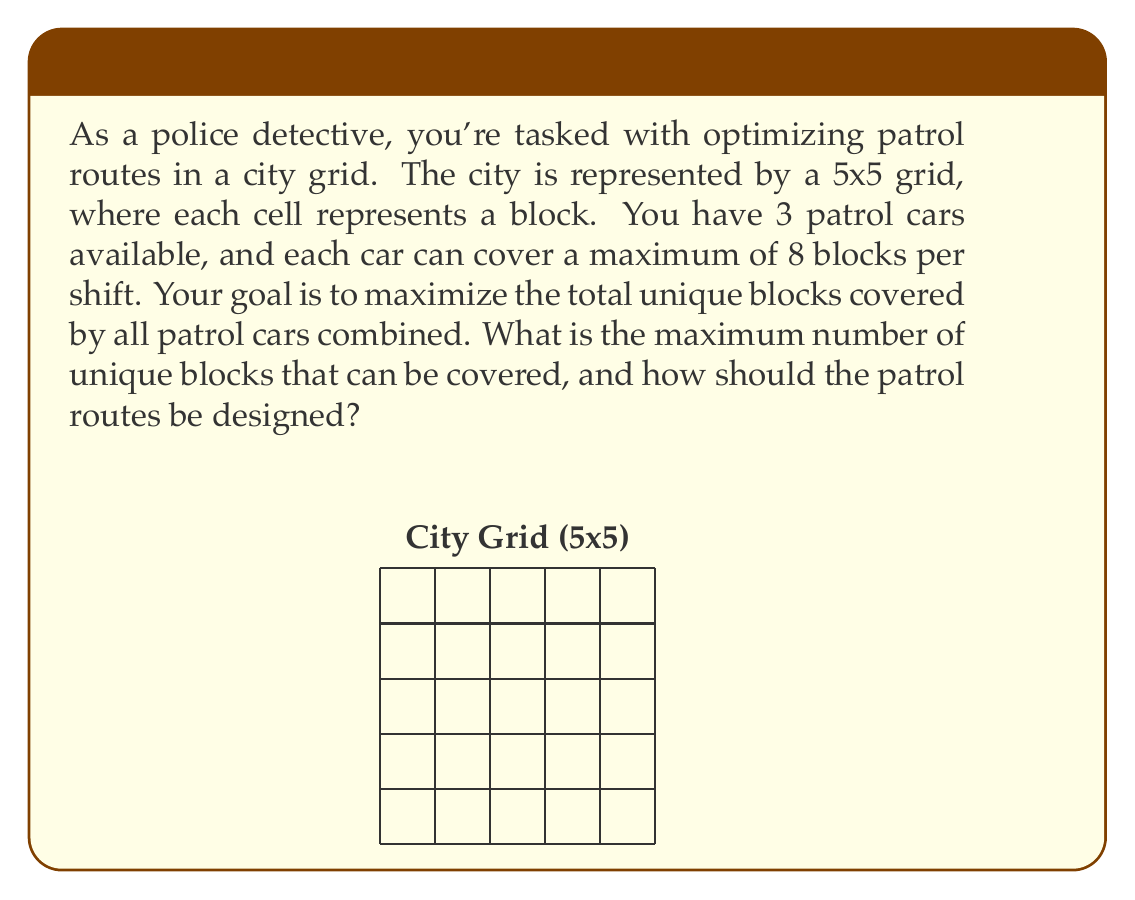Teach me how to tackle this problem. To solve this optimization problem, we need to consider the following:

1. The total area of the city grid is 5 x 5 = 25 blocks.
2. We have 3 patrol cars, each covering a maximum of 8 blocks.
3. The goal is to maximize unique block coverage, avoiding overlap.

Let's approach this step-by-step:

1. If there was no overlap, the maximum coverage would be:
   $3 \text{ cars} \times 8 \text{ blocks} = 24 \text{ blocks}$

2. However, we need to ensure that the routes are feasible within the 5x5 grid.

3. The optimal solution is to design routes that cover the maximum area with minimal overlap. One possible arrangement is:

   [asy]
   unitsize(1cm);
   for(int i=0; i<=5; ++i) {
     draw((0,i)--(5,i));
     draw((i,0)--(i,5));
   }
   draw((0,0)--(3,0)--(3,2)--(0,2)--cycle, blue);
   draw((2,2)--(5,2)--(5,4)--(2,4)--cycle, red);
   draw((0,3)--(3,3)--(3,5)--(0,5)--cycle, green);
   label("Car 1", (1.5,1), blue);
   label("Car 2", (3.5,3), red);
   label("Car 3", (1.5,4), green);
   [/asy]

4. In this arrangement:
   - Car 1 covers 8 blocks (blue)
   - Car 2 covers 8 blocks (red)
   - Car 3 covers 8 blocks (green)

5. The total blocks covered are indeed 24, but there is an overlap of 1 block between Car 1 and Car 2.

6. Therefore, the total unique blocks covered are:
   $24 \text{ total blocks} - 1 \text{ overlapping block} = 23 \text{ unique blocks}$

This solution maximizes the coverage while respecting the constraints of the grid and the maximum blocks per car.
Answer: The maximum number of unique blocks that can be covered is 23, with patrol routes designed to cover the edges and center of the grid, minimizing overlap to just one block. 